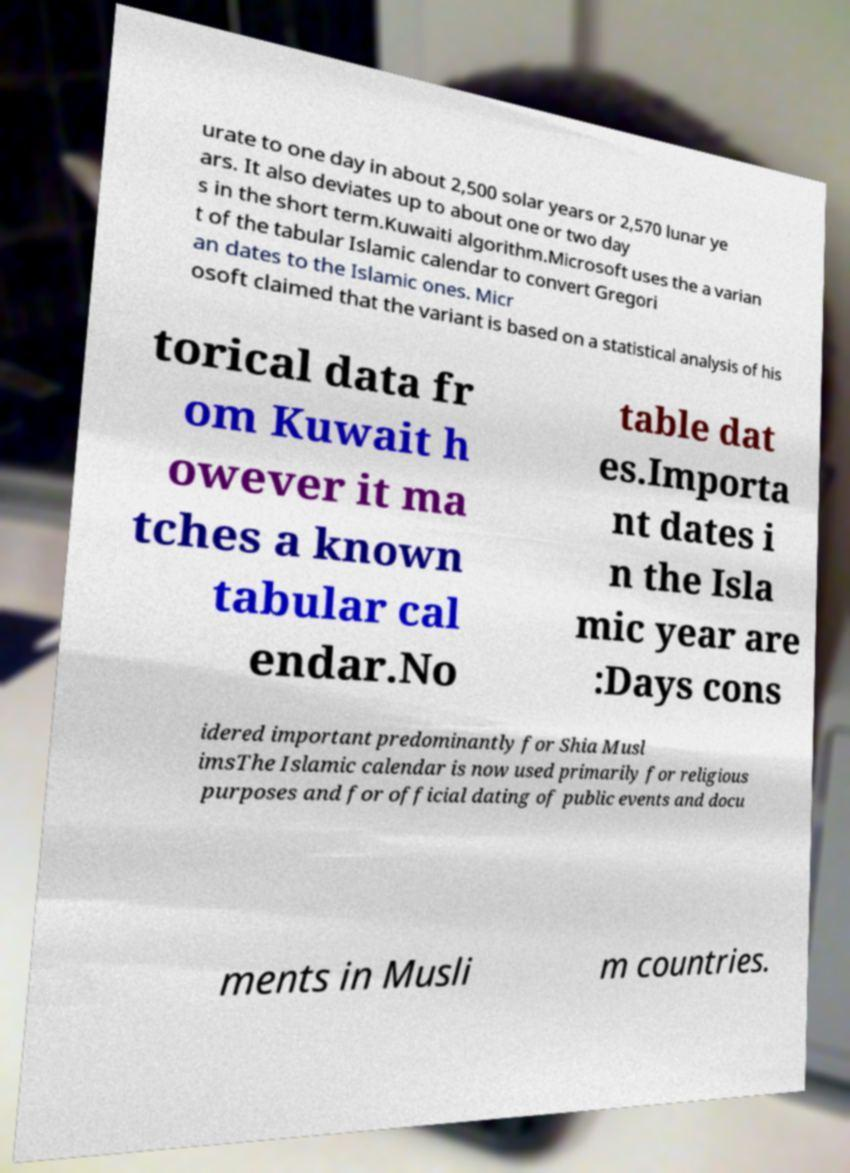Could you assist in decoding the text presented in this image and type it out clearly? urate to one day in about 2,500 solar years or 2,570 lunar ye ars. It also deviates up to about one or two day s in the short term.Kuwaiti algorithm.Microsoft uses the a varian t of the tabular Islamic calendar to convert Gregori an dates to the Islamic ones. Micr osoft claimed that the variant is based on a statistical analysis of his torical data fr om Kuwait h owever it ma tches a known tabular cal endar.No table dat es.Importa nt dates i n the Isla mic year are :Days cons idered important predominantly for Shia Musl imsThe Islamic calendar is now used primarily for religious purposes and for official dating of public events and docu ments in Musli m countries. 